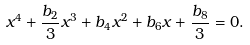Convert formula to latex. <formula><loc_0><loc_0><loc_500><loc_500>x ^ { 4 } + \frac { b _ { 2 } } { 3 } x ^ { 3 } + b _ { 4 } x ^ { 2 } + b _ { 6 } x + \frac { b _ { 8 } } { 3 } = 0 .</formula> 